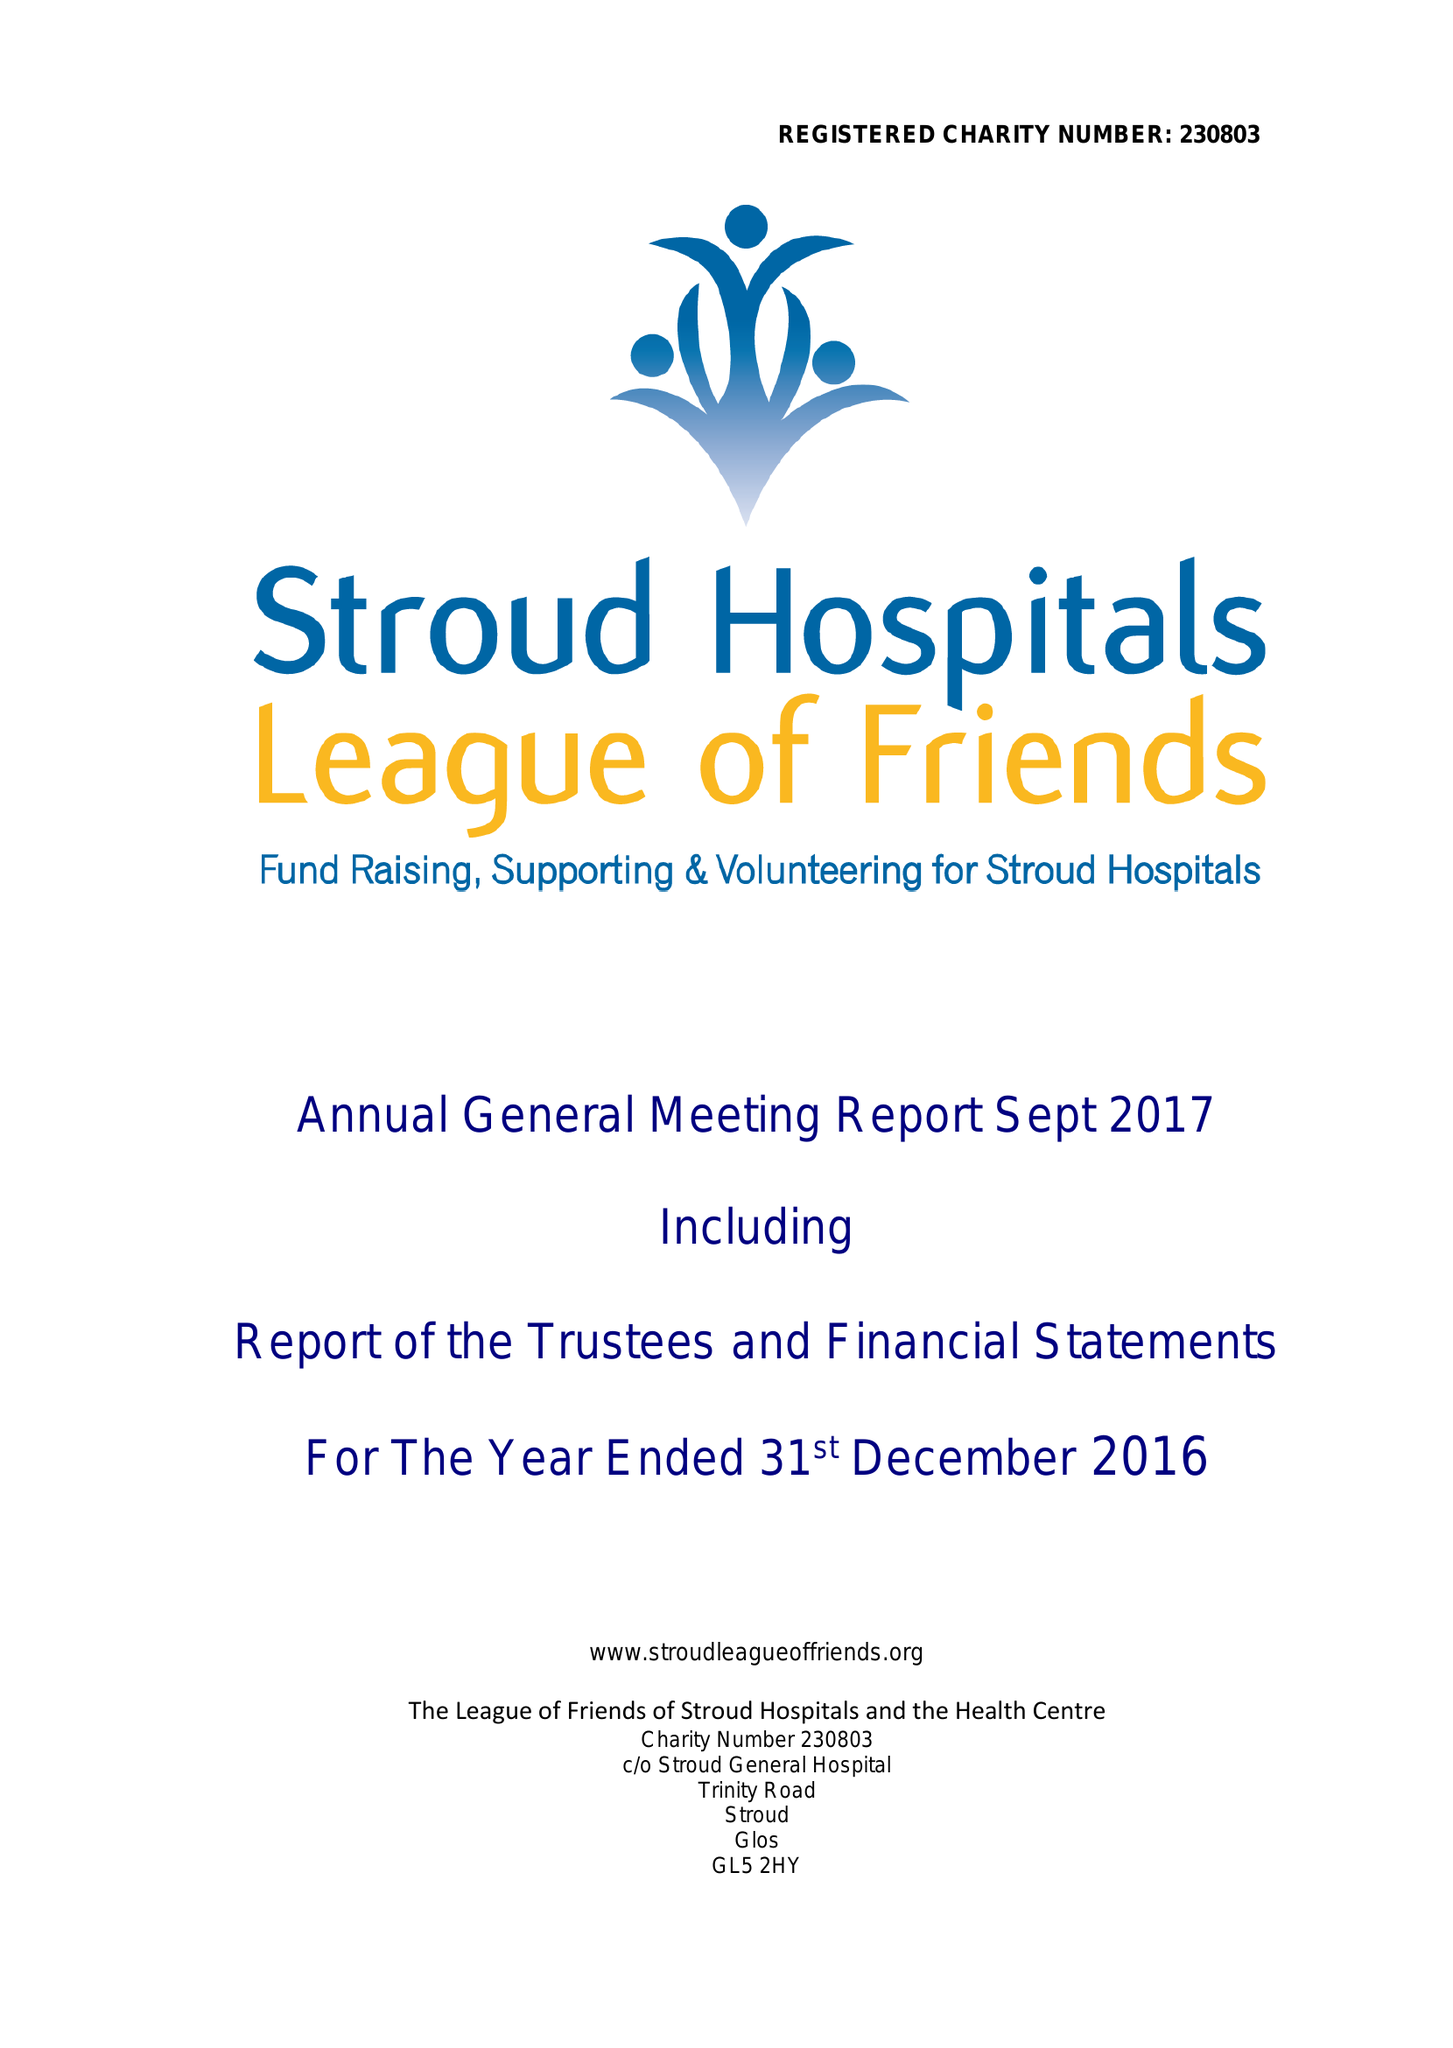What is the value for the address__street_line?
Answer the question using a single word or phrase. TRINITY ROAD 